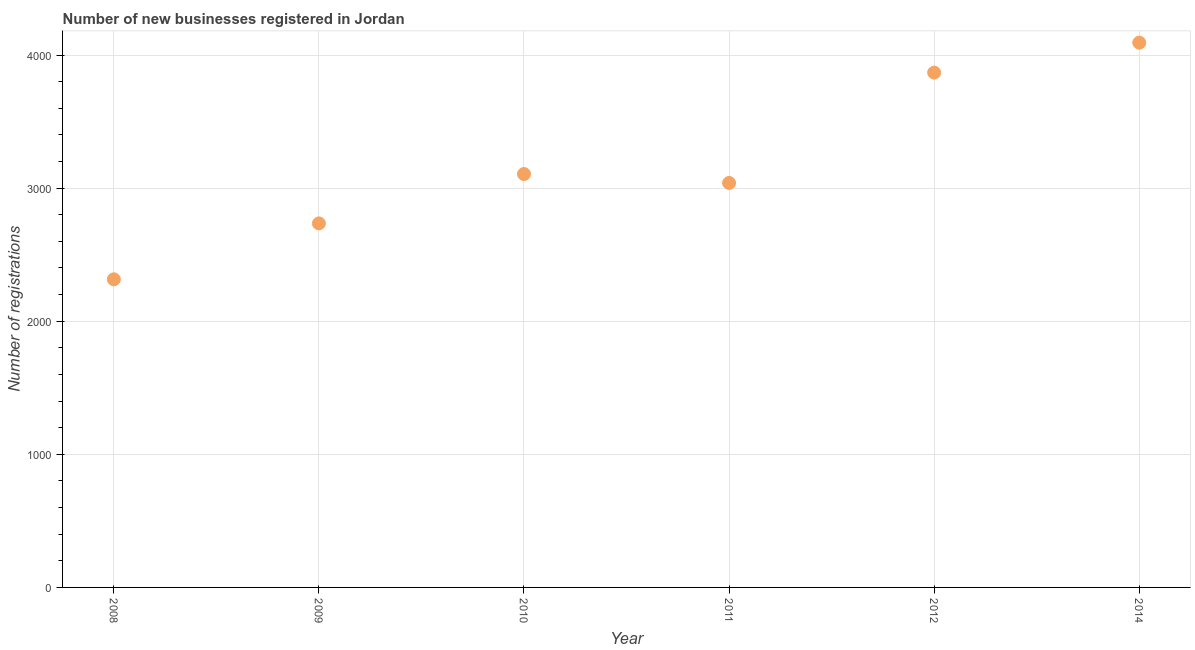What is the number of new business registrations in 2010?
Provide a succinct answer. 3106. Across all years, what is the maximum number of new business registrations?
Offer a terse response. 4093. Across all years, what is the minimum number of new business registrations?
Keep it short and to the point. 2315. In which year was the number of new business registrations minimum?
Provide a succinct answer. 2008. What is the sum of the number of new business registrations?
Give a very brief answer. 1.92e+04. What is the difference between the number of new business registrations in 2010 and 2011?
Your answer should be compact. 67. What is the average number of new business registrations per year?
Your answer should be very brief. 3192.67. What is the median number of new business registrations?
Provide a short and direct response. 3072.5. Do a majority of the years between 2010 and 2012 (inclusive) have number of new business registrations greater than 2600 ?
Offer a very short reply. Yes. What is the ratio of the number of new business registrations in 2012 to that in 2014?
Your answer should be compact. 0.95. Is the number of new business registrations in 2008 less than that in 2010?
Your response must be concise. Yes. What is the difference between the highest and the second highest number of new business registrations?
Offer a very short reply. 225. Is the sum of the number of new business registrations in 2008 and 2014 greater than the maximum number of new business registrations across all years?
Provide a succinct answer. Yes. What is the difference between the highest and the lowest number of new business registrations?
Your response must be concise. 1778. Does the number of new business registrations monotonically increase over the years?
Give a very brief answer. No. What is the title of the graph?
Your answer should be compact. Number of new businesses registered in Jordan. What is the label or title of the Y-axis?
Keep it short and to the point. Number of registrations. What is the Number of registrations in 2008?
Provide a short and direct response. 2315. What is the Number of registrations in 2009?
Ensure brevity in your answer.  2735. What is the Number of registrations in 2010?
Give a very brief answer. 3106. What is the Number of registrations in 2011?
Your answer should be very brief. 3039. What is the Number of registrations in 2012?
Your answer should be compact. 3868. What is the Number of registrations in 2014?
Your answer should be compact. 4093. What is the difference between the Number of registrations in 2008 and 2009?
Give a very brief answer. -420. What is the difference between the Number of registrations in 2008 and 2010?
Provide a short and direct response. -791. What is the difference between the Number of registrations in 2008 and 2011?
Offer a terse response. -724. What is the difference between the Number of registrations in 2008 and 2012?
Offer a terse response. -1553. What is the difference between the Number of registrations in 2008 and 2014?
Offer a terse response. -1778. What is the difference between the Number of registrations in 2009 and 2010?
Your answer should be compact. -371. What is the difference between the Number of registrations in 2009 and 2011?
Offer a very short reply. -304. What is the difference between the Number of registrations in 2009 and 2012?
Offer a very short reply. -1133. What is the difference between the Number of registrations in 2009 and 2014?
Give a very brief answer. -1358. What is the difference between the Number of registrations in 2010 and 2012?
Provide a succinct answer. -762. What is the difference between the Number of registrations in 2010 and 2014?
Keep it short and to the point. -987. What is the difference between the Number of registrations in 2011 and 2012?
Your answer should be compact. -829. What is the difference between the Number of registrations in 2011 and 2014?
Offer a very short reply. -1054. What is the difference between the Number of registrations in 2012 and 2014?
Offer a very short reply. -225. What is the ratio of the Number of registrations in 2008 to that in 2009?
Make the answer very short. 0.85. What is the ratio of the Number of registrations in 2008 to that in 2010?
Your response must be concise. 0.74. What is the ratio of the Number of registrations in 2008 to that in 2011?
Offer a very short reply. 0.76. What is the ratio of the Number of registrations in 2008 to that in 2012?
Provide a succinct answer. 0.6. What is the ratio of the Number of registrations in 2008 to that in 2014?
Offer a very short reply. 0.57. What is the ratio of the Number of registrations in 2009 to that in 2010?
Provide a short and direct response. 0.88. What is the ratio of the Number of registrations in 2009 to that in 2011?
Keep it short and to the point. 0.9. What is the ratio of the Number of registrations in 2009 to that in 2012?
Your answer should be very brief. 0.71. What is the ratio of the Number of registrations in 2009 to that in 2014?
Give a very brief answer. 0.67. What is the ratio of the Number of registrations in 2010 to that in 2012?
Provide a succinct answer. 0.8. What is the ratio of the Number of registrations in 2010 to that in 2014?
Ensure brevity in your answer.  0.76. What is the ratio of the Number of registrations in 2011 to that in 2012?
Offer a terse response. 0.79. What is the ratio of the Number of registrations in 2011 to that in 2014?
Offer a terse response. 0.74. What is the ratio of the Number of registrations in 2012 to that in 2014?
Provide a succinct answer. 0.94. 